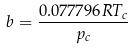Convert formula to latex. <formula><loc_0><loc_0><loc_500><loc_500>b = \frac { 0 . 0 7 7 7 9 6 R T _ { c } } { p _ { c } }</formula> 